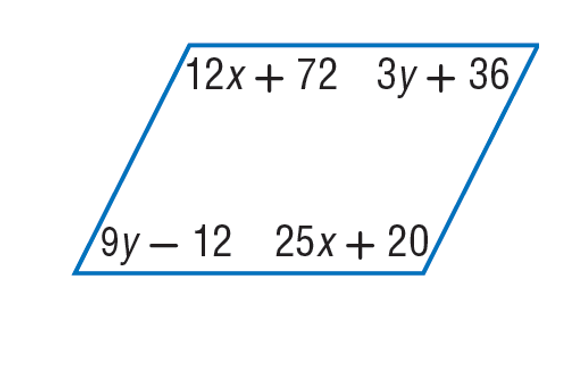Question: Find x so that the quadrilateral is a parallelogram.
Choices:
A. 4
B. 12
C. 25
D. 45
Answer with the letter. Answer: A Question: Find y so that the quadrilateral is a parallelogram.
Choices:
A. 8
B. 9
C. 25
D. 96
Answer with the letter. Answer: A 